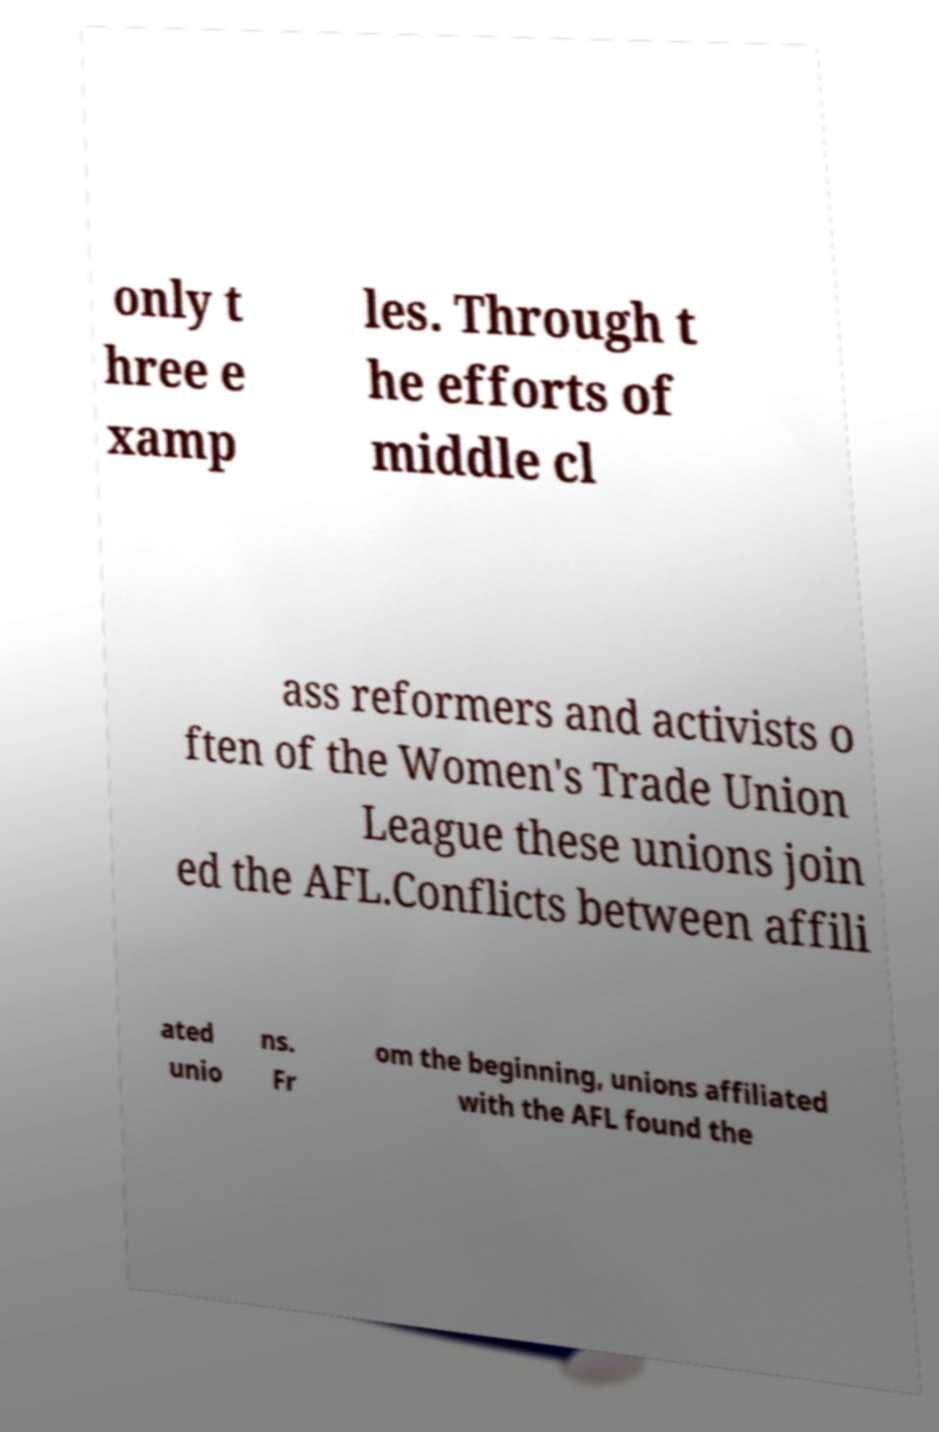Can you accurately transcribe the text from the provided image for me? only t hree e xamp les. Through t he efforts of middle cl ass reformers and activists o ften of the Women's Trade Union League these unions join ed the AFL.Conflicts between affili ated unio ns. Fr om the beginning, unions affiliated with the AFL found the 